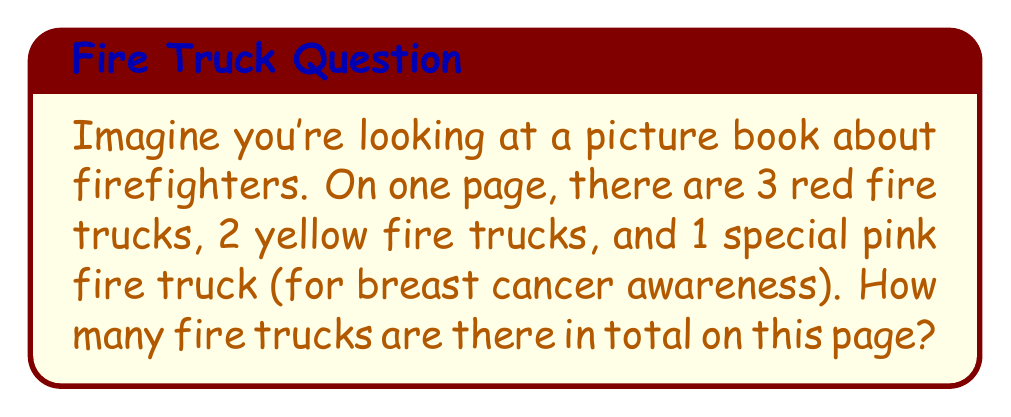Help me with this question. Let's break this down step by step:

1. First, we need to identify the different types of fire trucks:
   - Red fire trucks: 3
   - Yellow fire trucks: 2
   - Pink fire truck: 1

2. To find the total number of fire trucks, we need to add all of these together:

   $$\text{Total} = \text{Red} + \text{Yellow} + \text{Pink}$$

3. Now, let's substitute the numbers:

   $$\text{Total} = 3 + 2 + 1$$

4. Finally, we perform the addition:

   $$\text{Total} = 6$$

So, there are 6 fire trucks in total on this page of the picture book.
Answer: $6$ fire trucks 